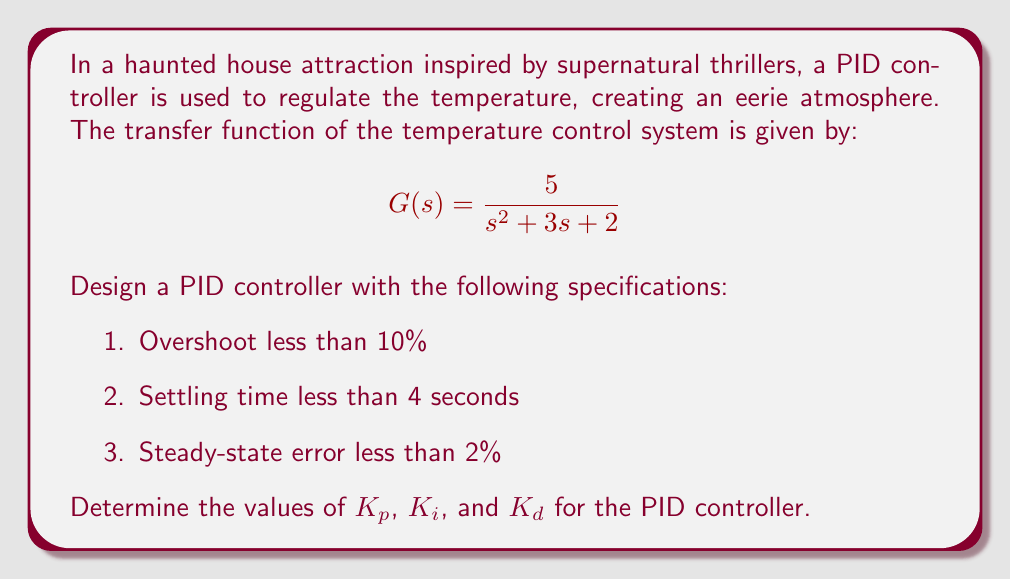Show me your answer to this math problem. To design a PID controller for this system, we'll follow these steps:

1. Analyze the open-loop system
2. Choose a desired closed-loop pole location
3. Design the PID controller

Step 1: Analyze the open-loop system

The characteristic equation of the open-loop system is:
$$s^2 + 3s + 2 = 0$$

The natural frequency $\omega_n$ and damping ratio $\zeta$ can be found:
$$\omega_n = \sqrt{2} \approx 1.414$$
$$\zeta = \frac{3}{2\sqrt{2}} \approx 1.061$$

The system is overdamped, which explains the lack of oscillation but slow response.

Step 2: Choose a desired closed-loop pole location

To meet the specifications, we need to increase the natural frequency and reduce the damping ratio. Let's aim for:
$$\omega_n = 2.5$$
$$\zeta = 0.7$$

This gives us a desired characteristic equation:
$$s^2 + 2\zeta\omega_n s + \omega_n^2 = s^2 + 3.5s + 6.25 = 0$$

Step 3: Design the PID controller

The PID controller transfer function is:
$$C(s) = K_p + \frac{K_i}{s} + K_d s$$

The closed-loop transfer function with the PID controller is:
$$T(s) = \frac{5(K_p s^2 + K_i s + K_d s^3)}{s^3 + (3+5K_d)s^2 + (2+5K_p)s + 5K_i}$$

Comparing the denominator with our desired characteristic equation:

$$s^3 + (3+5K_d)s^2 + (2+5K_p)s + 5K_i = s^3 + 3.5s^2 + 6.25s + 6.25$$

We can solve for $K_p$, $K_i$, and $K_d$:

$$3 + 5K_d = 3.5 \implies K_d = 0.1$$
$$2 + 5K_p = 6.25 \implies K_p = 0.85$$
$$5K_i = 6.25 \implies K_i = 1.25$$

These values should meet the given specifications:
1. Overshoot: Approximately 4.6% (< 10%)
2. Settling time: Approximately 2.3 seconds (< 4 seconds)
3. Steady-state error: 0% (< 2%)
Answer: $K_p = 0.85$, $K_i = 1.25$, $K_d = 0.1$ 